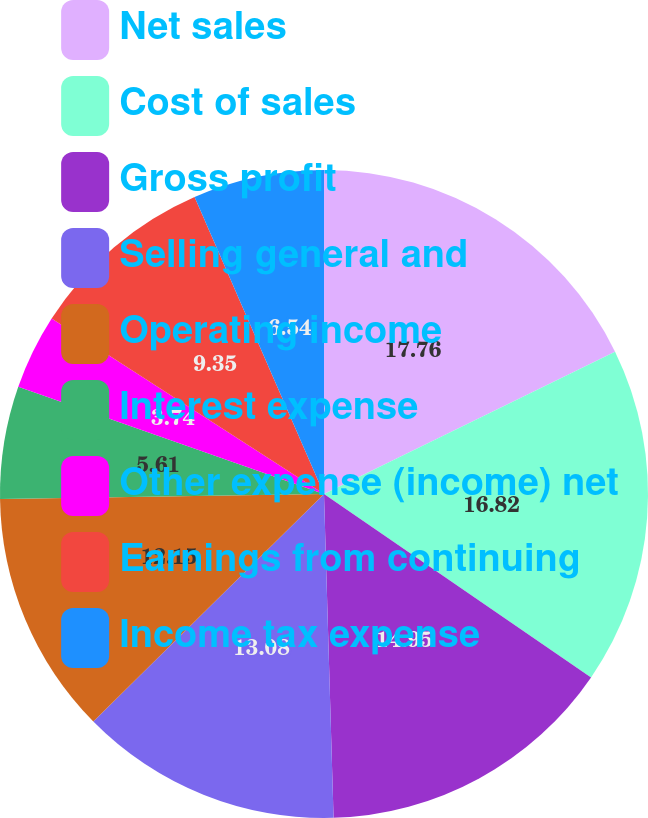<chart> <loc_0><loc_0><loc_500><loc_500><pie_chart><fcel>Net sales<fcel>Cost of sales<fcel>Gross profit<fcel>Selling general and<fcel>Operating income<fcel>Interest expense<fcel>Other expense (income) net<fcel>Earnings from continuing<fcel>Income tax expense<nl><fcel>17.76%<fcel>16.82%<fcel>14.95%<fcel>13.08%<fcel>12.15%<fcel>5.61%<fcel>3.74%<fcel>9.35%<fcel>6.54%<nl></chart> 